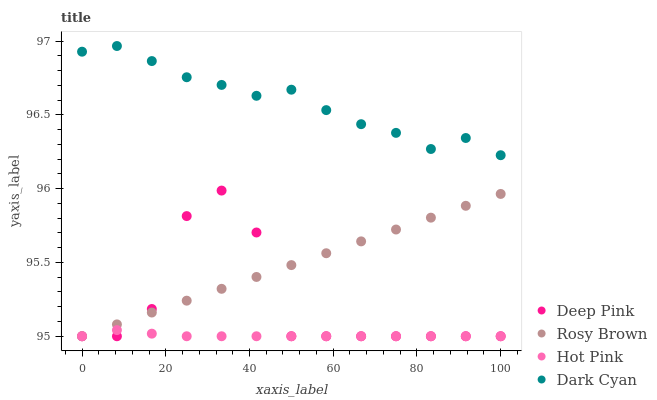Does Hot Pink have the minimum area under the curve?
Answer yes or no. Yes. Does Dark Cyan have the maximum area under the curve?
Answer yes or no. Yes. Does Rosy Brown have the minimum area under the curve?
Answer yes or no. No. Does Rosy Brown have the maximum area under the curve?
Answer yes or no. No. Is Rosy Brown the smoothest?
Answer yes or no. Yes. Is Deep Pink the roughest?
Answer yes or no. Yes. Is Deep Pink the smoothest?
Answer yes or no. No. Is Rosy Brown the roughest?
Answer yes or no. No. Does Rosy Brown have the lowest value?
Answer yes or no. Yes. Does Dark Cyan have the highest value?
Answer yes or no. Yes. Does Rosy Brown have the highest value?
Answer yes or no. No. Is Hot Pink less than Dark Cyan?
Answer yes or no. Yes. Is Dark Cyan greater than Hot Pink?
Answer yes or no. Yes. Does Hot Pink intersect Deep Pink?
Answer yes or no. Yes. Is Hot Pink less than Deep Pink?
Answer yes or no. No. Is Hot Pink greater than Deep Pink?
Answer yes or no. No. Does Hot Pink intersect Dark Cyan?
Answer yes or no. No. 